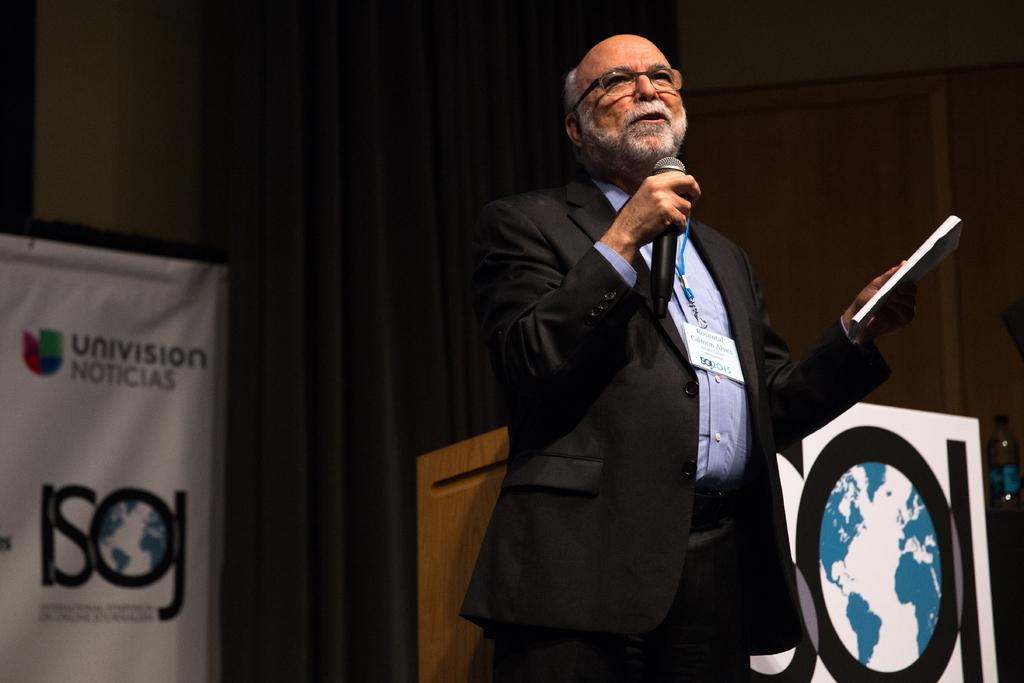What is the man in the image doing? The man is standing and talking on a microphone. What is the man holding in the image? The man is holding a paper. What can be seen in the background of the image? There is a banner in the background of the image. What object is present in the image that the man might be using for support or as a reference? There is a podium in the image. What type of trees can be seen in the image? There are no trees visible in the image. What brand of toothpaste is the man using in the image? There is no toothpaste present in the image. 